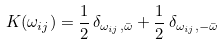Convert formula to latex. <formula><loc_0><loc_0><loc_500><loc_500>K ( \omega _ { i j } ) = \frac { 1 } { 2 } \, \delta _ { \omega _ { i j } , \bar { \omega } } + \frac { 1 } { 2 } \, \delta _ { \omega _ { i j } , - \bar { \omega } }</formula> 